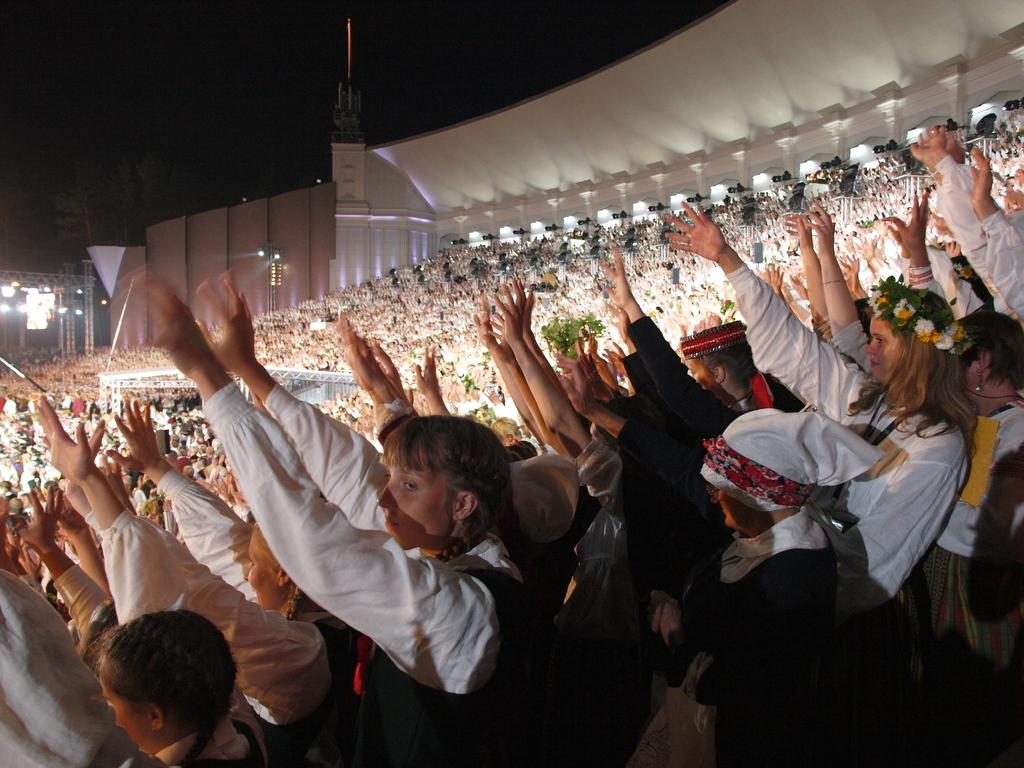What is the main subject of the image? The main subject of the image is a crowd of people. What else can be seen in the image besides the crowd? There are lights visible in the image, as well as a shelter. How would you describe the sky in the image? The sky appears dark in the image. What type of flesh can be seen in the image? There is no flesh visible in the image. Is there a field present in the image? There is no field present in the image. 